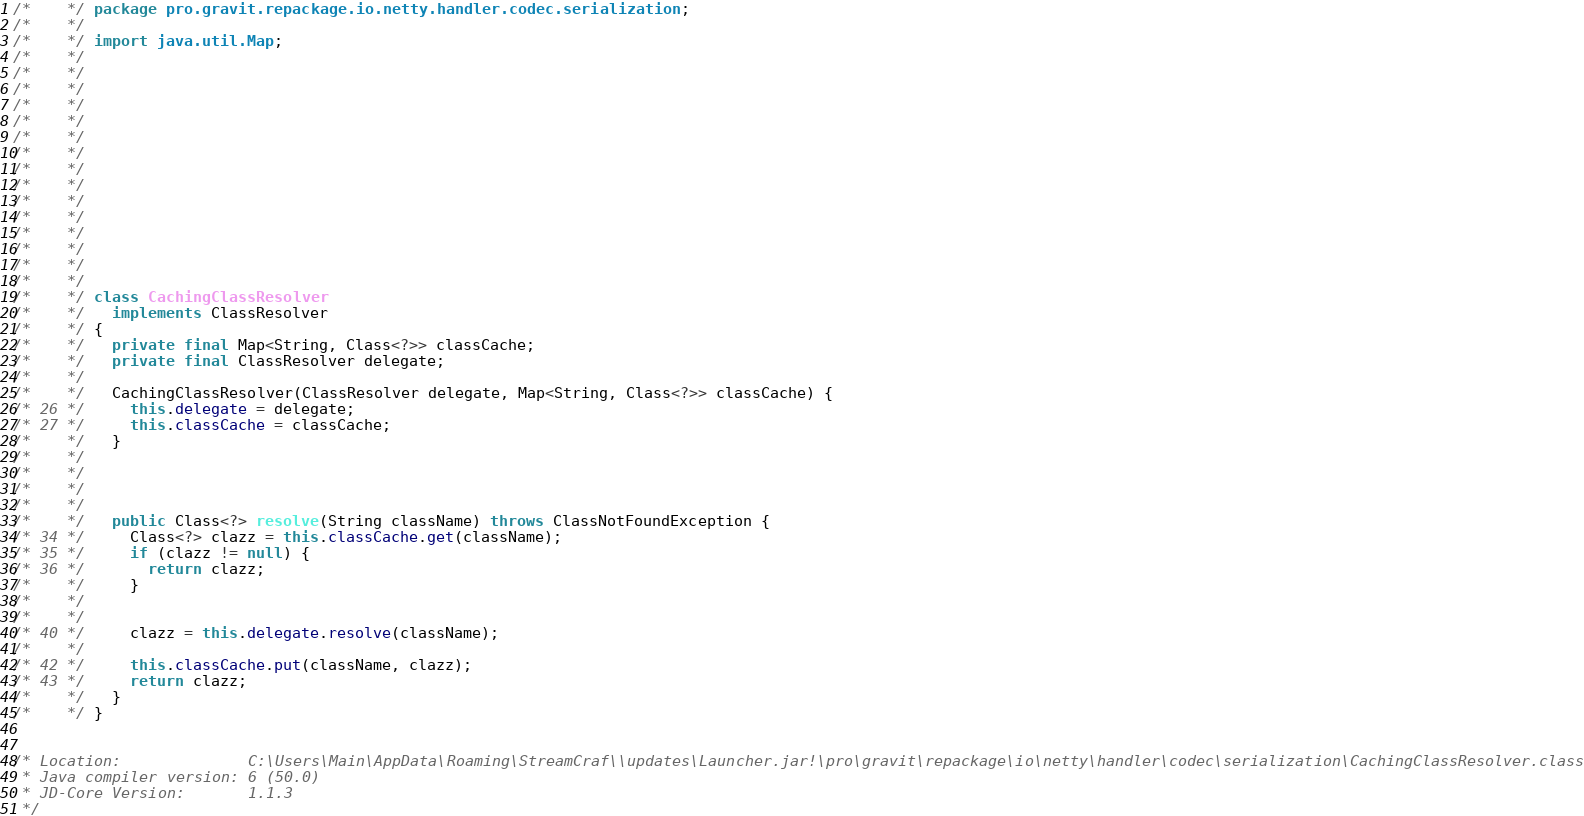Convert code to text. <code><loc_0><loc_0><loc_500><loc_500><_Java_>/*    */ package pro.gravit.repackage.io.netty.handler.codec.serialization;
/*    */ 
/*    */ import java.util.Map;
/*    */ 
/*    */ 
/*    */ 
/*    */ 
/*    */ 
/*    */ 
/*    */ 
/*    */ 
/*    */ 
/*    */ 
/*    */ 
/*    */ 
/*    */ 
/*    */ 
/*    */ 
/*    */ class CachingClassResolver
/*    */   implements ClassResolver
/*    */ {
/*    */   private final Map<String, Class<?>> classCache;
/*    */   private final ClassResolver delegate;
/*    */   
/*    */   CachingClassResolver(ClassResolver delegate, Map<String, Class<?>> classCache) {
/* 26 */     this.delegate = delegate;
/* 27 */     this.classCache = classCache;
/*    */   }
/*    */ 
/*    */ 
/*    */ 
/*    */   
/*    */   public Class<?> resolve(String className) throws ClassNotFoundException {
/* 34 */     Class<?> clazz = this.classCache.get(className);
/* 35 */     if (clazz != null) {
/* 36 */       return clazz;
/*    */     }
/*    */ 
/*    */     
/* 40 */     clazz = this.delegate.resolve(className);
/*    */     
/* 42 */     this.classCache.put(className, clazz);
/* 43 */     return clazz;
/*    */   }
/*    */ }


/* Location:              C:\Users\Main\AppData\Roaming\StreamCraf\\updates\Launcher.jar!\pro\gravit\repackage\io\netty\handler\codec\serialization\CachingClassResolver.class
 * Java compiler version: 6 (50.0)
 * JD-Core Version:       1.1.3
 */</code> 